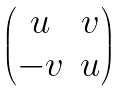Convert formula to latex. <formula><loc_0><loc_0><loc_500><loc_500>\begin{pmatrix} u & v \\ - v & u \end{pmatrix}</formula> 